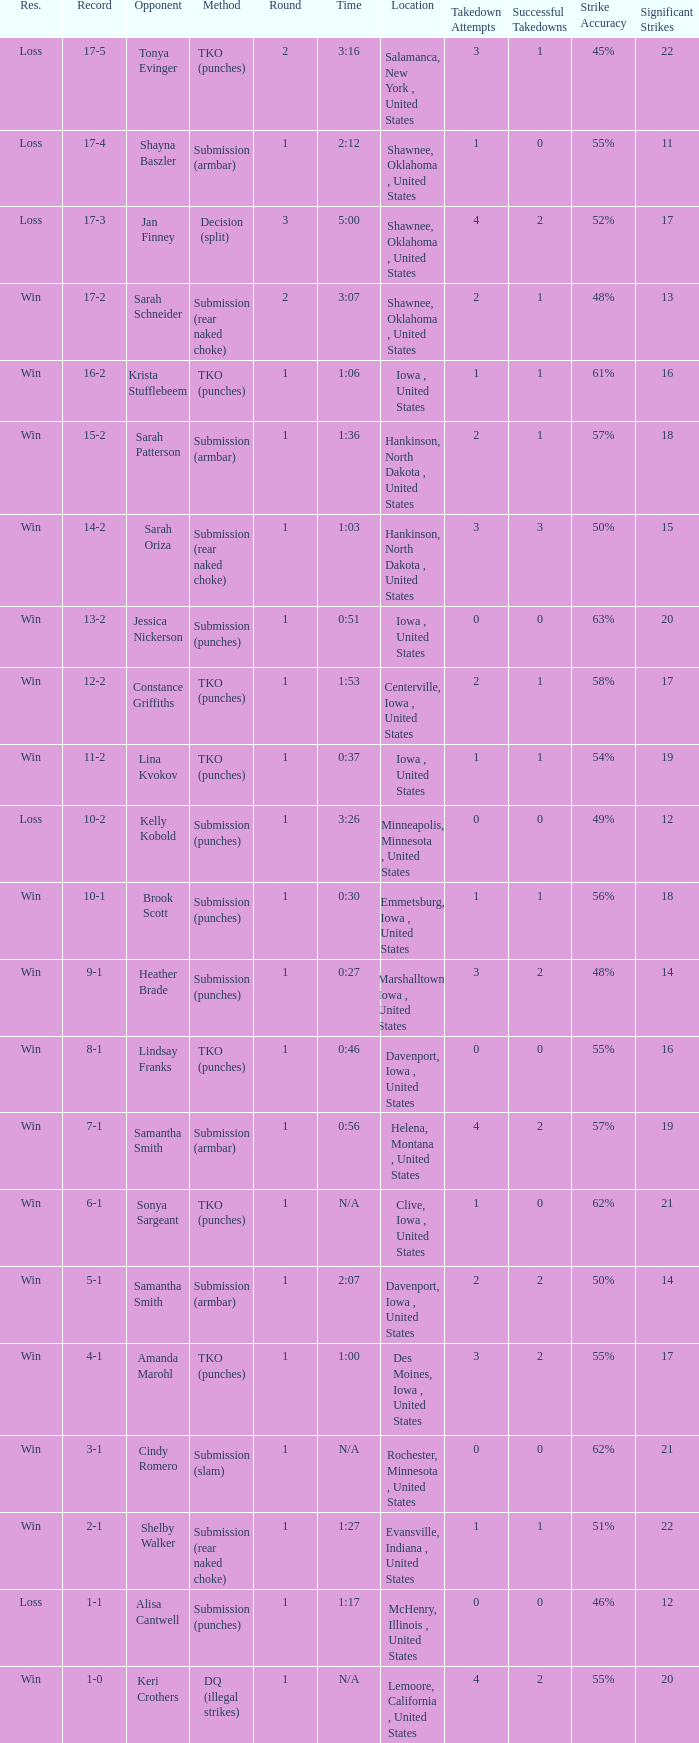What is the highest number of rounds for a 3:16 fight? 2.0. 